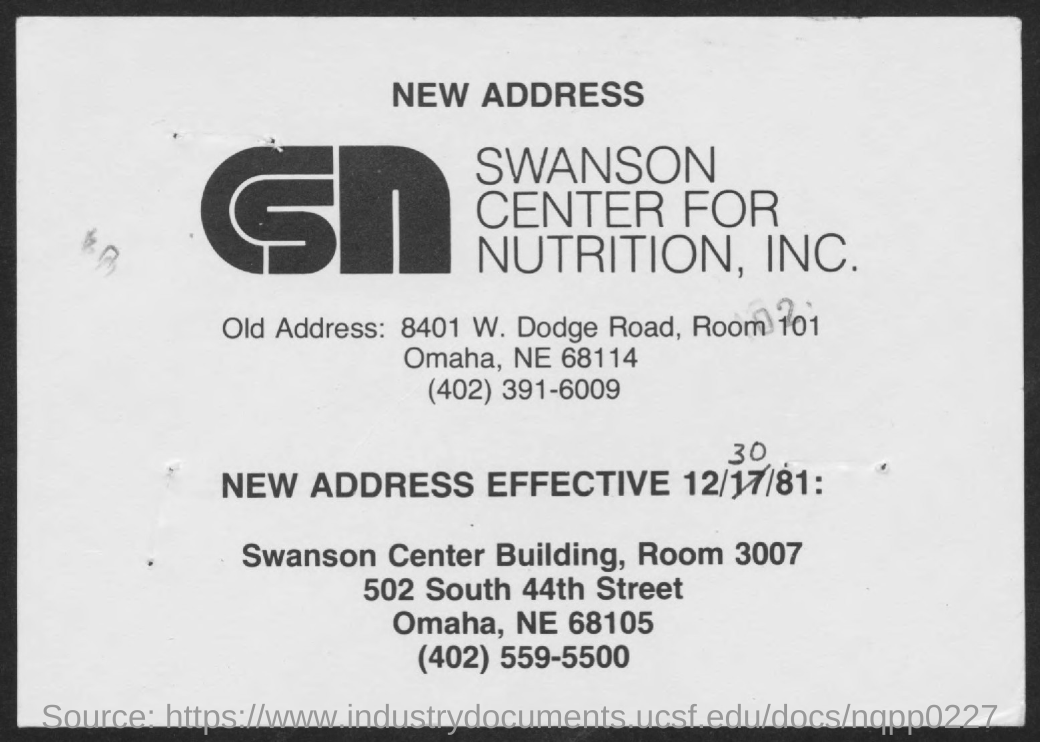When is the new address effective?
Offer a very short reply. 12/30/81. 